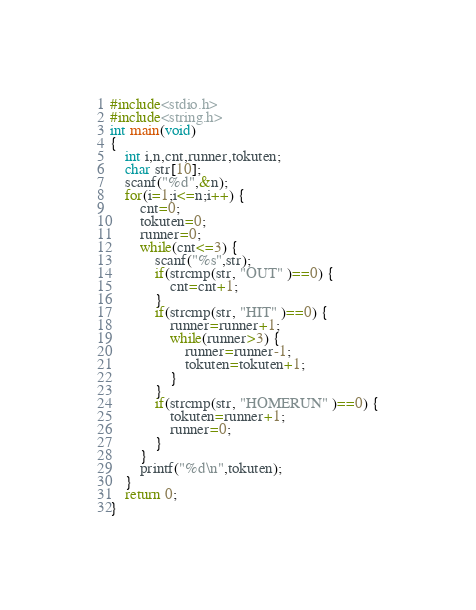<code> <loc_0><loc_0><loc_500><loc_500><_C_>#include<stdio.h>
#include<string.h>
int main(void)
{
	int i,n,cnt,runner,tokuten;
	char str[10];
	scanf("%d",&n);
	for(i=1;i<=n;i++) {
		cnt=0;
		tokuten=0;
		runner=0;
		while(cnt<=3) {
			scanf("%s",str);
			if(strcmp(str, "OUT" )==0) {
				cnt=cnt+1;
			}
			if(strcmp(str, "HIT" )==0) {
				runner=runner+1;
				while(runner>3) {
					runner=runner-1;
					tokuten=tokuten+1;
				}
			}
			if(strcmp(str, "HOMERUN" )==0) {
				tokuten=runner+1;
				runner=0;
			}
		}
		printf("%d\n",tokuten);
	}
	return 0;
}</code> 